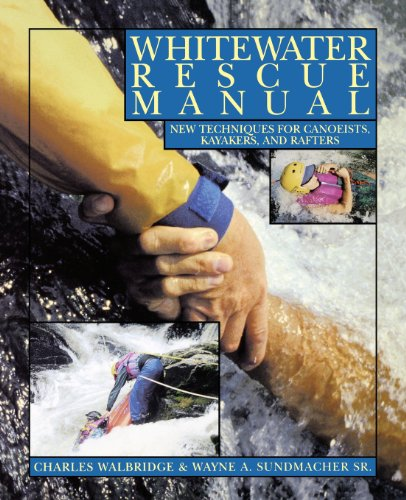Can beginners in kayaking benefit from reading this book? Absolutely, beginners will find this book immensely beneficial as it covers fundamental safety protocols and introduces new techniques specifically designed for novice kayakers, helping them to navigate and handle potentially hazardous situations with confidence. 